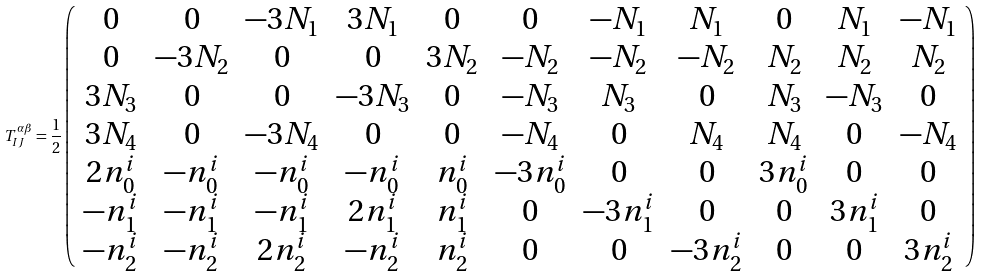Convert formula to latex. <formula><loc_0><loc_0><loc_500><loc_500>T _ { I J } ^ { \alpha \beta } = \frac { 1 } { 2 } \left ( \begin{array} { c c c c c c c c c c c } 0 & 0 & - 3 N _ { 1 } & 3 N _ { 1 } & 0 & 0 & - N _ { 1 } & N _ { 1 } & 0 & N _ { 1 } & - N _ { 1 } \\ 0 & - 3 N _ { 2 } & 0 & 0 & 3 N _ { 2 } & - N _ { 2 } & - N _ { 2 } & - N _ { 2 } & N _ { 2 } & N _ { 2 } & N _ { 2 } \\ 3 N _ { 3 } & 0 & 0 & - 3 N _ { 3 } & 0 & - N _ { 3 } & N _ { 3 } & 0 & N _ { 3 } & - N _ { 3 } & 0 \\ 3 N _ { 4 } & 0 & - 3 N _ { 4 } & 0 & 0 & - N _ { 4 } & 0 & N _ { 4 } & N _ { 4 } & 0 & - N _ { 4 } \\ 2 n _ { 0 } ^ { i } & - n _ { 0 } ^ { i } & - n _ { 0 } ^ { i } & - n _ { 0 } ^ { i } & n _ { 0 } ^ { i } & - 3 n _ { 0 } ^ { i } & 0 & 0 & 3 n _ { 0 } ^ { i } & 0 & 0 \\ - n _ { 1 } ^ { i } & - n _ { 1 } ^ { i } & - n _ { 1 } ^ { i } & 2 n _ { 1 } ^ { i } & n _ { 1 } ^ { i } & 0 & - 3 n _ { 1 } ^ { i } & 0 & 0 & 3 n _ { 1 } ^ { i } & 0 \\ - n _ { 2 } ^ { i } & - n _ { 2 } ^ { i } & 2 n _ { 2 } ^ { i } & - n _ { 2 } ^ { i } & n _ { 2 } ^ { i } & 0 & 0 & - 3 n _ { 2 } ^ { i } & 0 & 0 & 3 n _ { 2 } ^ { i } \\ \end{array} \right )</formula> 